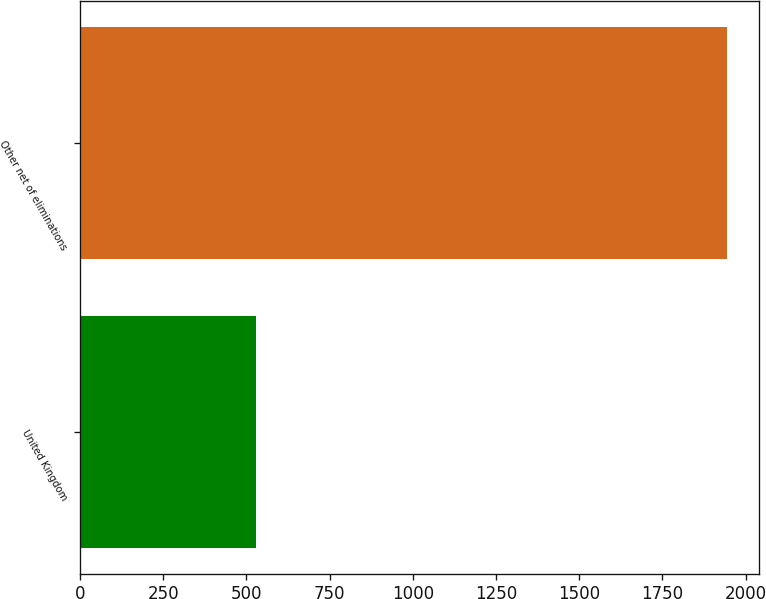Convert chart. <chart><loc_0><loc_0><loc_500><loc_500><bar_chart><fcel>United Kingdom<fcel>Other net of eliminations<nl><fcel>528<fcel>1944<nl></chart> 